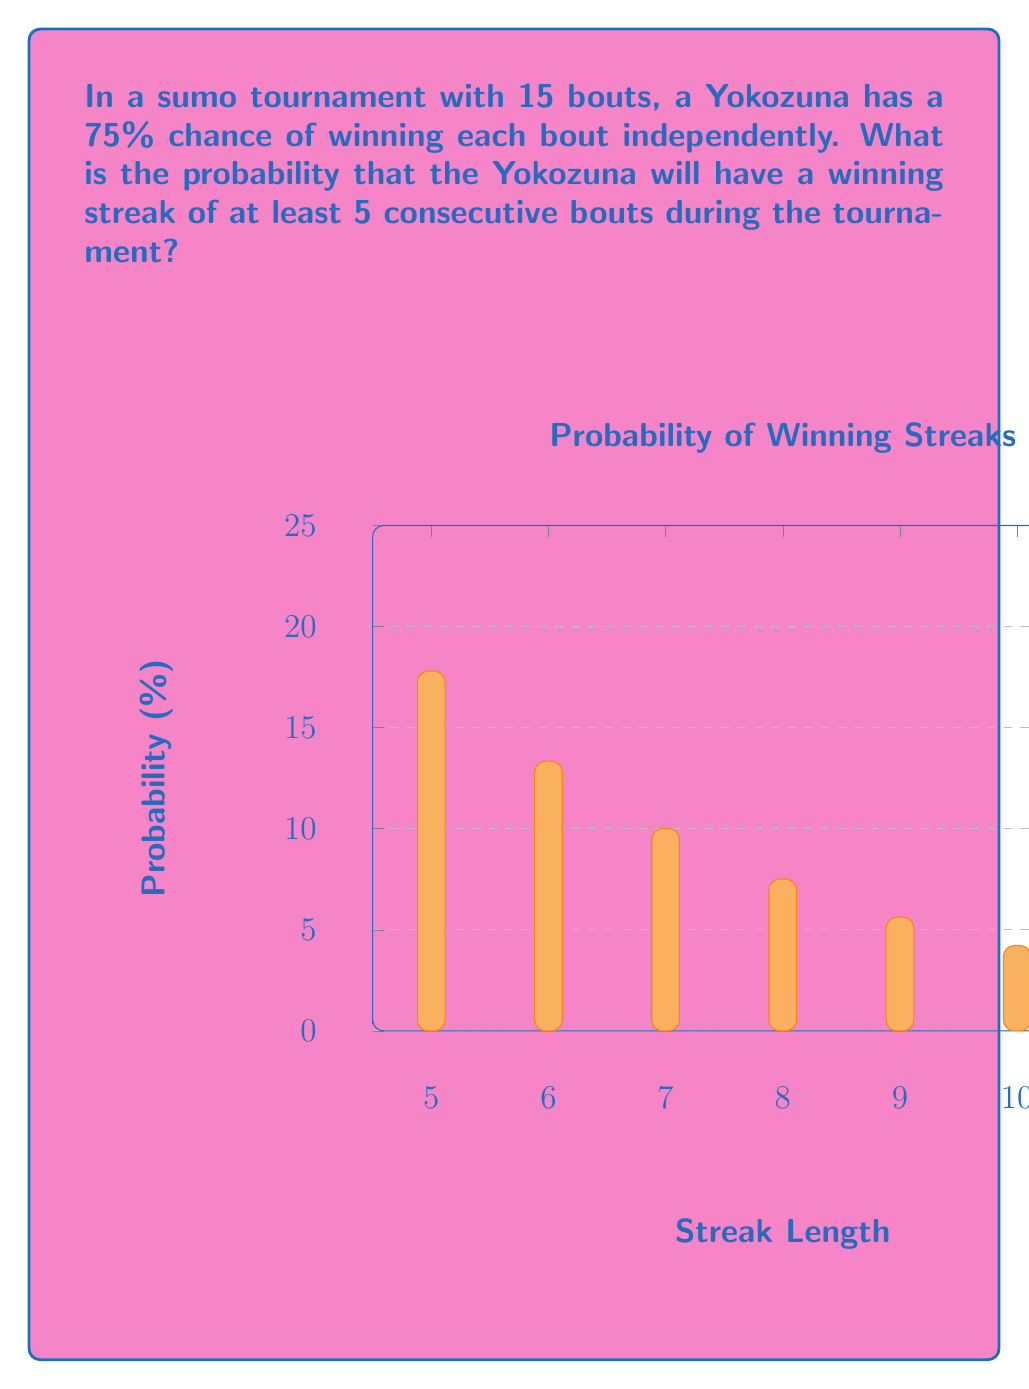Provide a solution to this math problem. Let's approach this step-by-step:

1) First, we need to calculate the probability of a streak of exactly 5 wins, then 6 wins, and so on up to 15 wins.

2) For a streak of exactly k wins starting at a specific position, the probability is:
   $P(\text{streak of k}) = 0.75^k \cdot 0.25$ (if k < 15)
   $P(\text{streak of 15}) = 0.75^{15}$

3) Now, we need to consider all possible starting positions for each streak length. For a streak of k wins in a 15-bout tournament, there are 16-k possible starting positions.

4) The probability of at least one streak of k or more is the complement of the probability of no such streaks. Let's call this probability $P(k+)$.

5) Using the inclusion-exclusion principle:

   $P(5+) = 1 - P(\text{no streaks of 5 or more})$
   
   $= 1 - (1 - 11 \cdot 0.75^5 \cdot 0.25 - 10 \cdot 0.75^6 \cdot 0.25 - 9 \cdot 0.75^7 \cdot 0.25 - ... - 0.75^{15})$

6) Calculating this:

   $P(5+) = 1 - (1 - 11 \cdot 0.2373 \cdot 0.25 - 10 \cdot 0.1780 \cdot 0.25 - 9 \cdot 0.1335 \cdot 0.25 - ... - 0.0134)$
   
   $= 1 - 0.2008$
   
   $= 0.7992$

7) Converting to a percentage: 0.7992 * 100 = 79.92%

Therefore, the probability of the Yokozuna having a winning streak of at least 5 consecutive bouts during the 15-bout tournament is approximately 79.92%.
Answer: 79.92% 